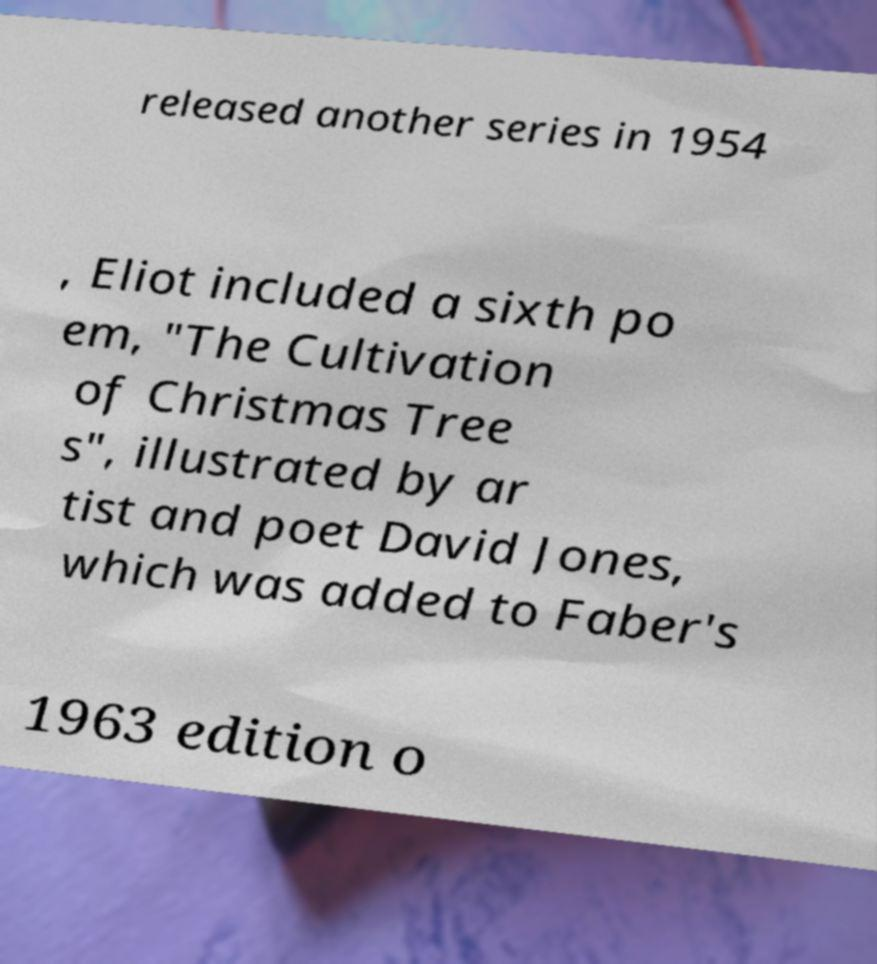Please identify and transcribe the text found in this image. released another series in 1954 , Eliot included a sixth po em, "The Cultivation of Christmas Tree s", illustrated by ar tist and poet David Jones, which was added to Faber's 1963 edition o 